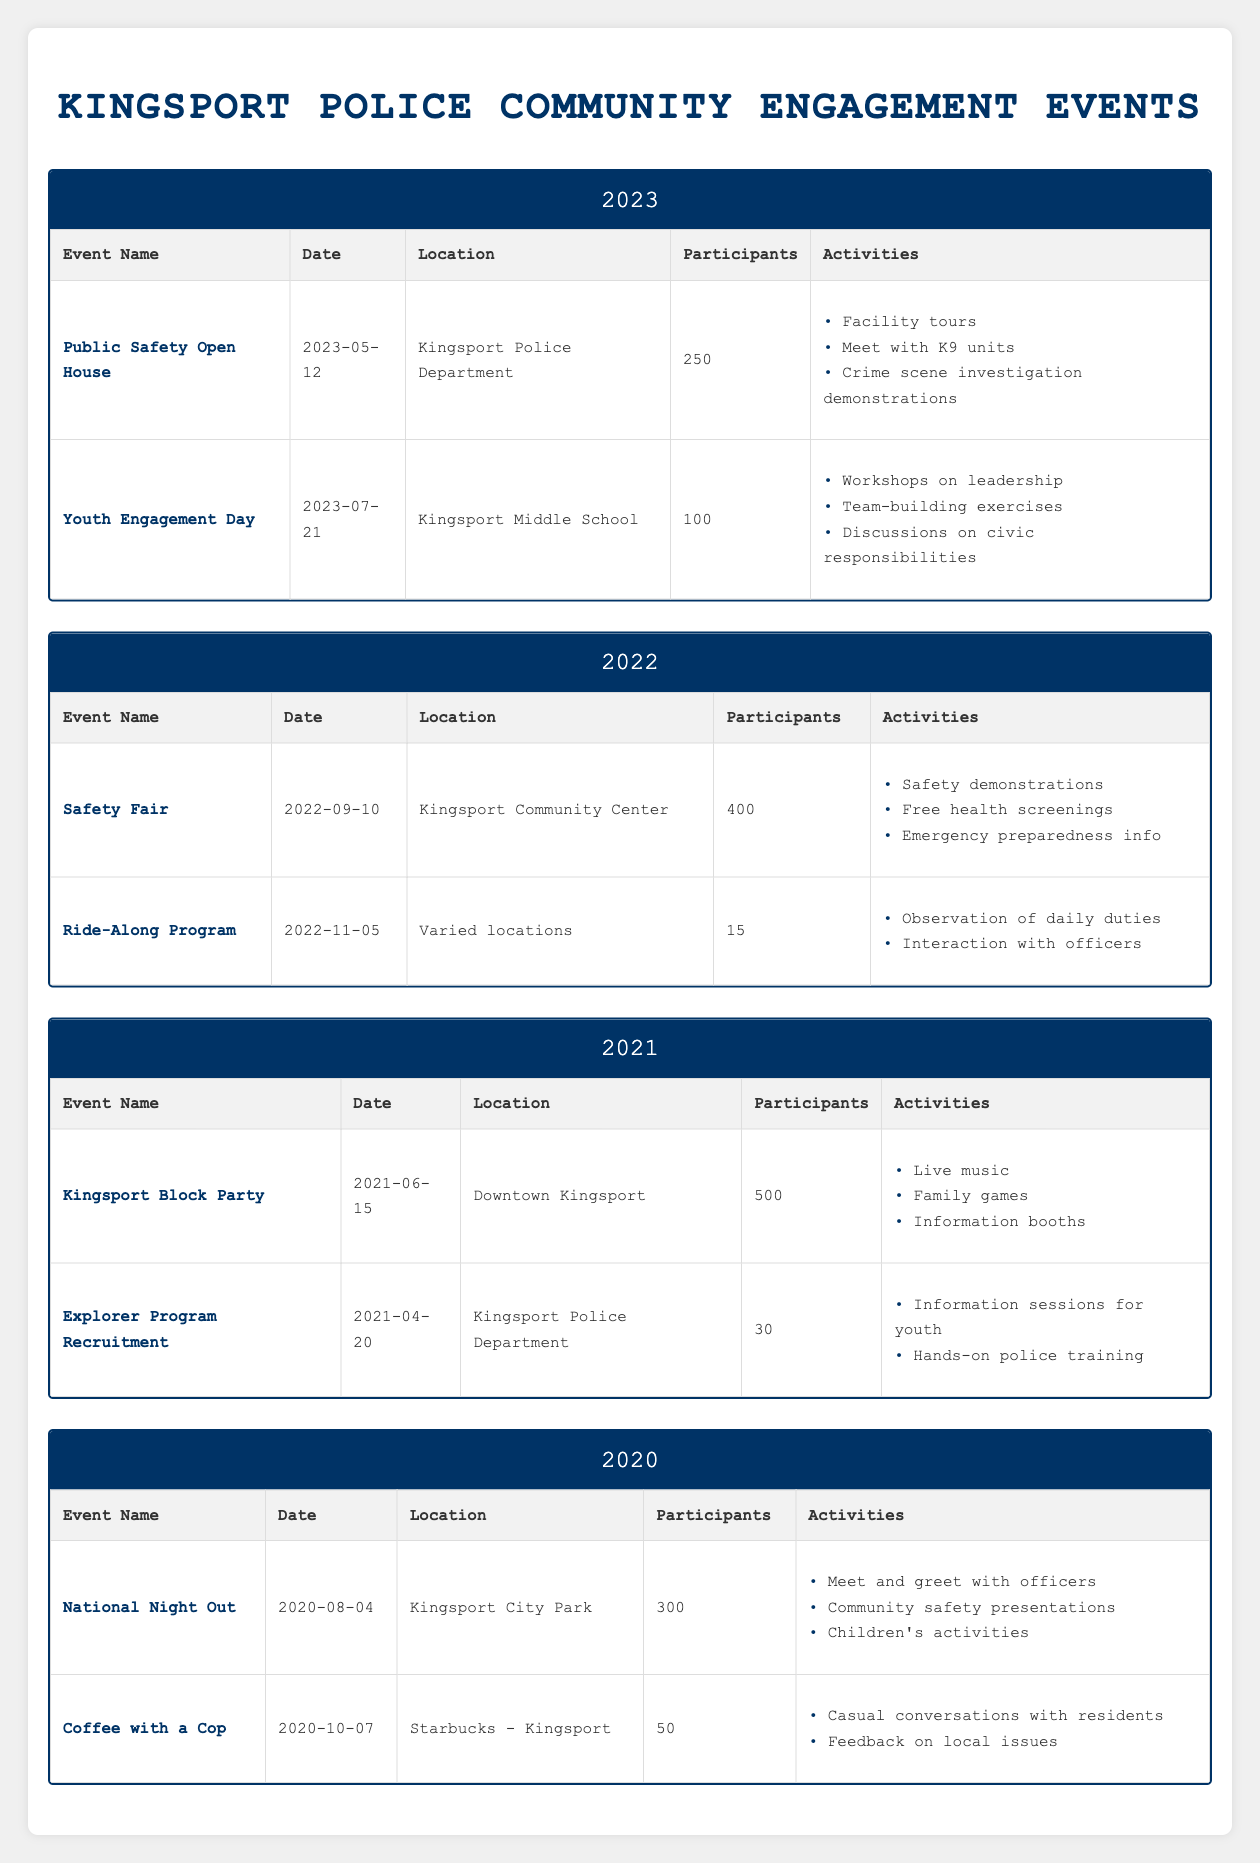What was the location of the National Night Out event? The event National Night Out took place on 2020-08-04 at Kingsport City Park, according to the table.
Answer: Kingsport City Park How many participants attended the Kingsport Block Party? According to the table, the Kingsport Block Party held on 2021-06-15 had 500 participants.
Answer: 500 Which event had the least number of participants in 2022? The table shows that the Ride-Along Program had the least number of participants with 15 on 2022-11-05, whereas the Safety Fair had 400 participants.
Answer: Ride-Along Program What is the total number of participants across all events in 2021? Adding the participants: 500 (Kingsport Block Party) + 30 (Explorer Program Recruitment) = 530. Therefore, the total number of participants in 2021 is 530.
Answer: 530 Did the Public Safety Open House have more participants than the Youth Engagement Day? The Public Safety Open House had 250 participants and the Youth Engagement Day had 100 participants. Therefore, it is true that the Public Safety Open House had more participants.
Answer: Yes Which year hosted the Safety Fair event? The table shows that the Safety Fair took place in 2022, specifically on 2022-09-10, as per the event details for that year.
Answer: 2022 What activities were included in the Coffee with a Cop event? The Coffee with a Cop event had activities including "Casual conversations with residents" and "Feedback on local issues," as listed in the table.
Answer: Casual conversations with residents, Feedback on local issues In which years did the Kingsport Police host events with more than 300 participants? The years with events having more than 300 participants are 2021 (Kingsport Block Party with 500), 2022 (Safety Fair with 400), and 2023 (Public Safety Open House with 250). Thus, excluding 2023, only 2021 and 2022 fit this criterion.
Answer: 2021, 2022 How many events were held in total across all the years listed in the table? The events are 2 in each year from 2020 to 2023, totaling (2 events per year × 4 years) = 8 events in total.
Answer: 8 Was there an event with fewer than 20 participants? According to the data in the table, the lowest number of participants was 15 for the Ride-Along Program in 2022. Thus, there was indeed an event with fewer than 20 participants.
Answer: Yes 